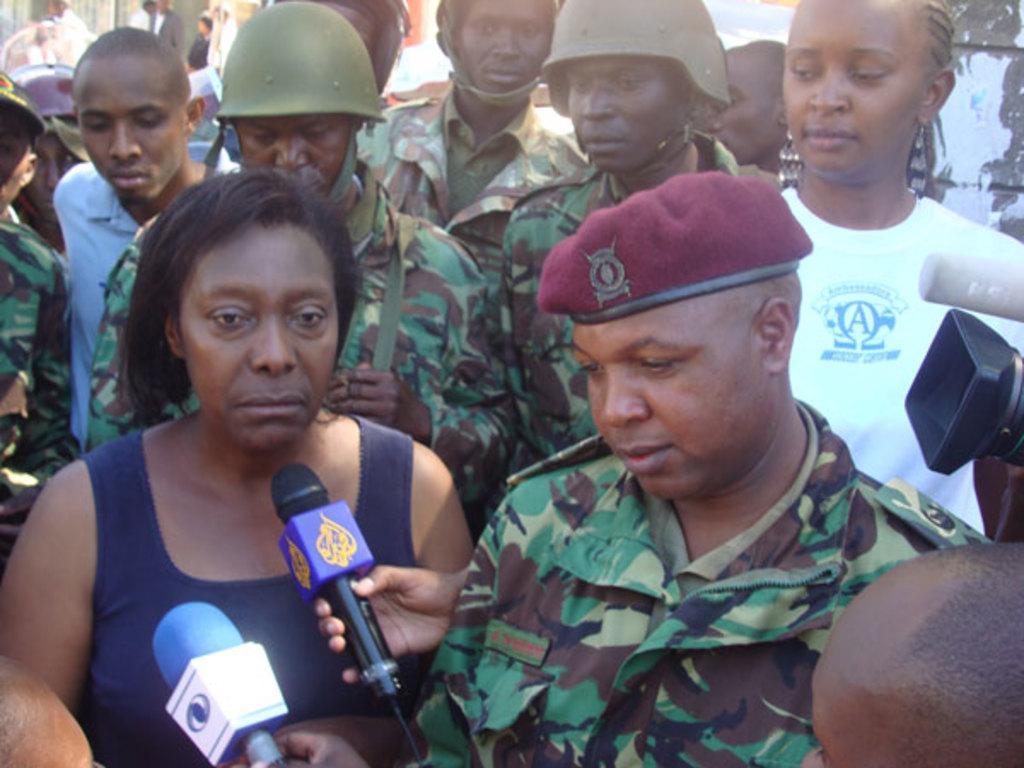Describe this image in one or two sentences. In this picture I can see a few people standing. I can see a few people wearing uniform. I can see the microphones. 